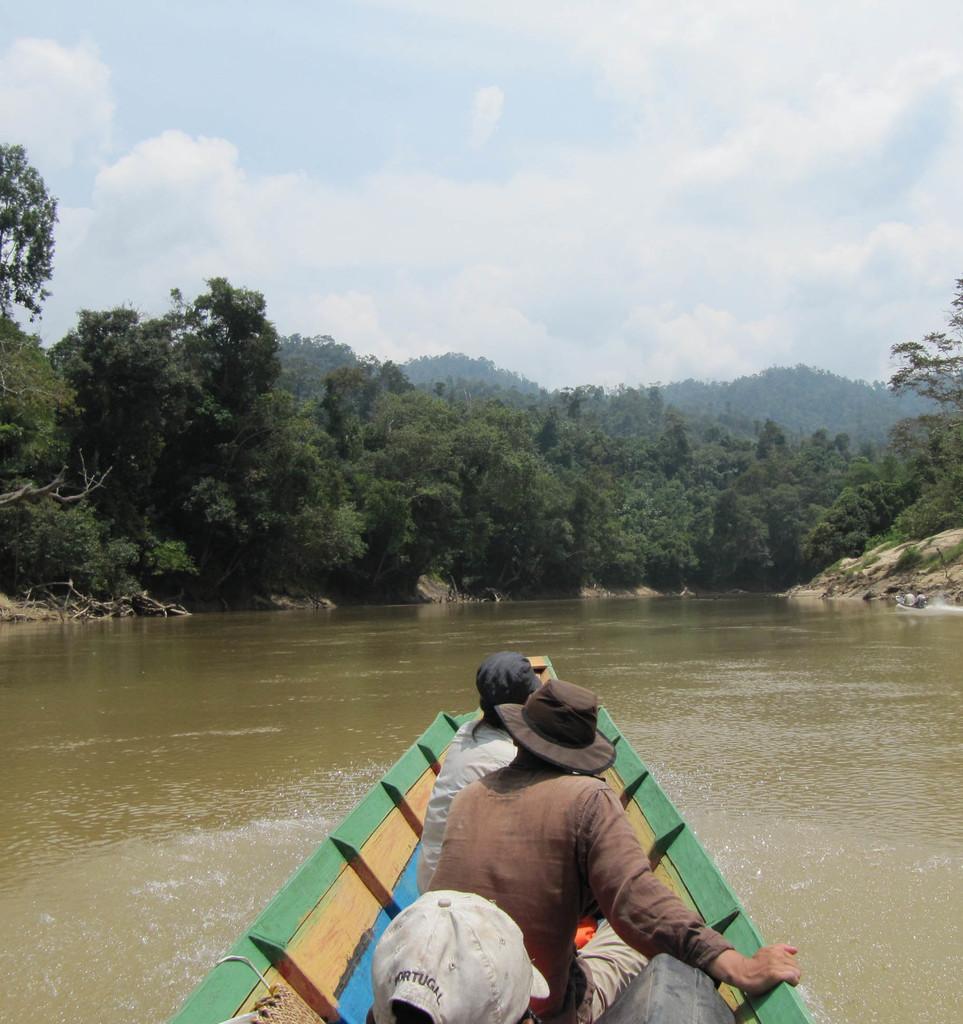What is happening at the bottom of the image? There are people on a boat at the bottom of the image. Can you describe any specific person in the image? A person with a cap is visible in the image. What type of environment is depicted in the background of the image? The background of the image includes water and trees. Are there any other people visible in the image? Yes, there are people visible in the background of the image. What can be seen in the sky in the image? The sky is visible in the background of the image. What type of wax is being used to polish the father's shirt in the image? There is no father or shirt present in the image, and therefore no wax is being used to polish anything. 